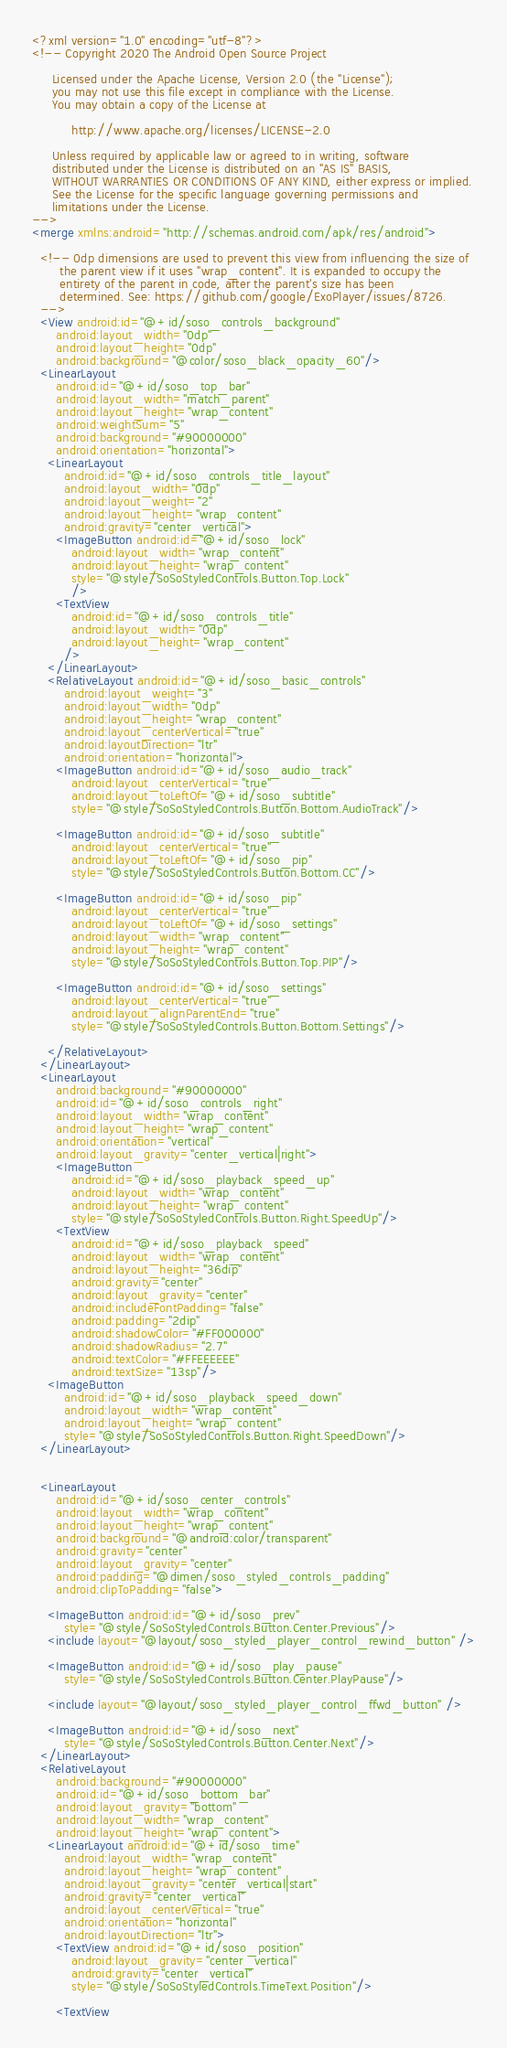Convert code to text. <code><loc_0><loc_0><loc_500><loc_500><_XML_><?xml version="1.0" encoding="utf-8"?>
<!-- Copyright 2020 The Android Open Source Project

     Licensed under the Apache License, Version 2.0 (the "License");
     you may not use this file except in compliance with the License.
     You may obtain a copy of the License at

          http://www.apache.org/licenses/LICENSE-2.0

     Unless required by applicable law or agreed to in writing, software
     distributed under the License is distributed on an "AS IS" BASIS,
     WITHOUT WARRANTIES OR CONDITIONS OF ANY KIND, either express or implied.
     See the License for the specific language governing permissions and
     limitations under the License.
-->
<merge xmlns:android="http://schemas.android.com/apk/res/android">

  <!-- 0dp dimensions are used to prevent this view from influencing the size of
       the parent view if it uses "wrap_content". It is expanded to occupy the
       entirety of the parent in code, after the parent's size has been
       determined. See: https://github.com/google/ExoPlayer/issues/8726.
  -->
  <View android:id="@+id/soso_controls_background"
      android:layout_width="0dp"
      android:layout_height="0dp"
      android:background="@color/soso_black_opacity_60"/>
  <LinearLayout
      android:id="@+id/soso_top_bar"
      android:layout_width="match_parent"
      android:layout_height="wrap_content"
      android:weightSum="5"
      android:background="#90000000"
      android:orientation="horizontal">
    <LinearLayout
        android:id="@+id/soso_controls_title_layout"
        android:layout_width="0dp"
        android:layout_weight="2"
        android:layout_height="wrap_content"
        android:gravity="center_vertical">
      <ImageButton android:id="@+id/soso_lock"
          android:layout_width="wrap_content"
          android:layout_height="wrap_content"
          style="@style/SoSoStyledControls.Button.Top.Lock"
          />
      <TextView
          android:id="@+id/soso_controls_title"
          android:layout_width="0dp"
          android:layout_height="wrap_content"
        />
    </LinearLayout>
    <RelativeLayout android:id="@+id/soso_basic_controls"
        android:layout_weight="3"
        android:layout_width="0dp"
        android:layout_height="wrap_content"
        android:layout_centerVertical="true"
        android:layoutDirection="ltr"
        android:orientation="horizontal">
      <ImageButton android:id="@+id/soso_audio_track"
          android:layout_centerVertical="true"
          android:layout_toLeftOf="@+id/soso_subtitle"
          style="@style/SoSoStyledControls.Button.Bottom.AudioTrack"/>
      
      <ImageButton android:id="@+id/soso_subtitle"
          android:layout_centerVertical="true"
          android:layout_toLeftOf="@+id/soso_pip"
          style="@style/SoSoStyledControls.Button.Bottom.CC"/>

      <ImageButton android:id="@+id/soso_pip"
          android:layout_centerVertical="true"
          android:layout_toLeftOf="@+id/soso_settings"
          android:layout_width="wrap_content"
          android:layout_height="wrap_content"
          style="@style/SoSoStyledControls.Button.Top.PIP"/>

      <ImageButton android:id="@+id/soso_settings"
          android:layout_centerVertical="true"
          android:layout_alignParentEnd="true"
          style="@style/SoSoStyledControls.Button.Bottom.Settings"/>

    </RelativeLayout>
  </LinearLayout>
  <LinearLayout
      android:background="#90000000"
      android:id="@+id/soso_controls_right"
      android:layout_width="wrap_content"
      android:layout_height="wrap_content"
      android:orientation="vertical"
      android:layout_gravity="center_vertical|right">
      <ImageButton
          android:id="@+id/soso_playback_speed_up"
          android:layout_width="wrap_content"
          android:layout_height="wrap_content"
          style="@style/SoSoStyledControls.Button.Right.SpeedUp"/>
      <TextView
          android:id="@+id/soso_playback_speed"
          android:layout_width="wrap_content"
          android:layout_height="36dip"
          android:gravity="center"
          android:layout_gravity="center"
          android:includeFontPadding="false"
          android:padding="2dip"
          android:shadowColor="#FF000000"
          android:shadowRadius="2.7"
          android:textColor="#FFEEEEEE"
          android:textSize="13sp"/>
    <ImageButton
        android:id="@+id/soso_playback_speed_down"
        android:layout_width="wrap_content"
        android:layout_height="wrap_content"
        style="@style/SoSoStyledControls.Button.Right.SpeedDown"/>
  </LinearLayout>


  <LinearLayout
      android:id="@+id/soso_center_controls"
      android:layout_width="wrap_content"
      android:layout_height="wrap_content"
      android:background="@android:color/transparent"
      android:gravity="center"
      android:layout_gravity="center"
      android:padding="@dimen/soso_styled_controls_padding"
      android:clipToPadding="false">

    <ImageButton android:id="@+id/soso_prev"
        style="@style/SoSoStyledControls.Button.Center.Previous"/>
    <include layout="@layout/soso_styled_player_control_rewind_button" />

    <ImageButton android:id="@+id/soso_play_pause"
        style="@style/SoSoStyledControls.Button.Center.PlayPause"/>

    <include layout="@layout/soso_styled_player_control_ffwd_button" />

    <ImageButton android:id="@+id/soso_next"
        style="@style/SoSoStyledControls.Button.Center.Next"/>
  </LinearLayout>
  <RelativeLayout
      android:background="#90000000"
      android:id="@+id/soso_bottom_bar"
      android:layout_gravity="bottom"
      android:layout_width="wrap_content"
      android:layout_height="wrap_content">
    <LinearLayout android:id="@+id/soso_time"
        android:layout_width="wrap_content"
        android:layout_height="wrap_content"
        android:layout_gravity="center_vertical|start"
        android:gravity="center_vertical"
        android:layout_centerVertical="true"
        android:orientation="horizontal"
        android:layoutDirection="ltr">
      <TextView android:id="@+id/soso_position"
          android:layout_gravity="center_vertical"
          android:gravity="center_vertical"
          style="@style/SoSoStyledControls.TimeText.Position"/>

      <TextView</code> 